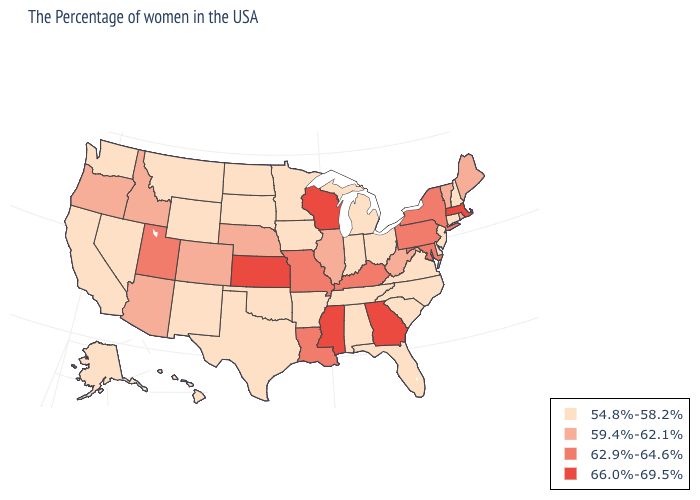Name the states that have a value in the range 54.8%-58.2%?
Be succinct. New Hampshire, Connecticut, New Jersey, Delaware, Virginia, North Carolina, South Carolina, Ohio, Florida, Michigan, Indiana, Alabama, Tennessee, Arkansas, Minnesota, Iowa, Oklahoma, Texas, South Dakota, North Dakota, Wyoming, New Mexico, Montana, Nevada, California, Washington, Alaska, Hawaii. Is the legend a continuous bar?
Quick response, please. No. What is the highest value in the USA?
Give a very brief answer. 66.0%-69.5%. What is the value of Louisiana?
Keep it brief. 62.9%-64.6%. What is the highest value in states that border Michigan?
Keep it brief. 66.0%-69.5%. Which states have the lowest value in the USA?
Concise answer only. New Hampshire, Connecticut, New Jersey, Delaware, Virginia, North Carolina, South Carolina, Ohio, Florida, Michigan, Indiana, Alabama, Tennessee, Arkansas, Minnesota, Iowa, Oklahoma, Texas, South Dakota, North Dakota, Wyoming, New Mexico, Montana, Nevada, California, Washington, Alaska, Hawaii. What is the value of Washington?
Answer briefly. 54.8%-58.2%. What is the value of Idaho?
Keep it brief. 59.4%-62.1%. What is the value of Colorado?
Concise answer only. 59.4%-62.1%. What is the lowest value in states that border Minnesota?
Quick response, please. 54.8%-58.2%. What is the value of Rhode Island?
Keep it brief. 59.4%-62.1%. Which states have the highest value in the USA?
Quick response, please. Massachusetts, Georgia, Wisconsin, Mississippi, Kansas. What is the value of Connecticut?
Concise answer only. 54.8%-58.2%. What is the value of Illinois?
Concise answer only. 59.4%-62.1%. Which states have the lowest value in the USA?
Write a very short answer. New Hampshire, Connecticut, New Jersey, Delaware, Virginia, North Carolina, South Carolina, Ohio, Florida, Michigan, Indiana, Alabama, Tennessee, Arkansas, Minnesota, Iowa, Oklahoma, Texas, South Dakota, North Dakota, Wyoming, New Mexico, Montana, Nevada, California, Washington, Alaska, Hawaii. 